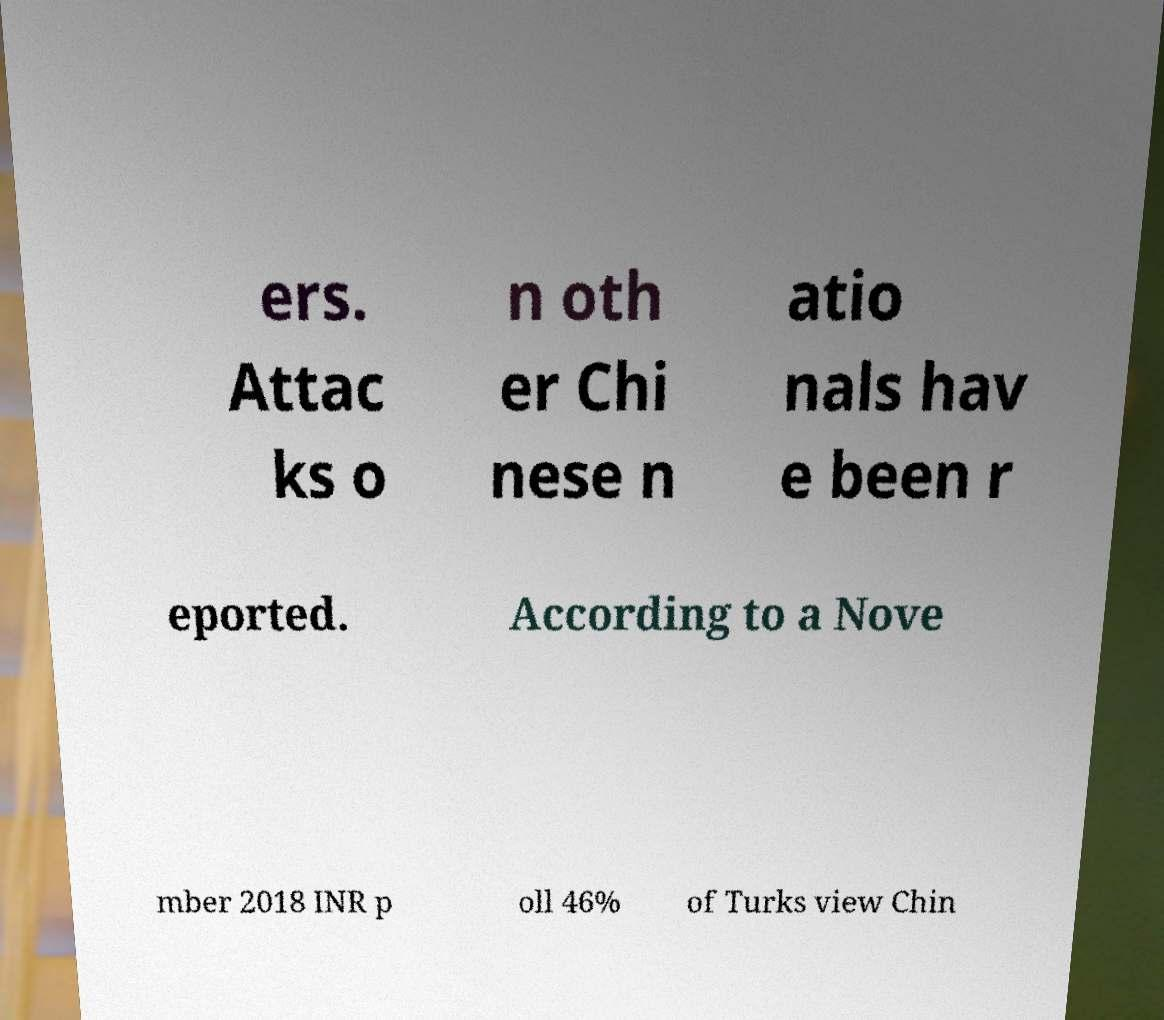I need the written content from this picture converted into text. Can you do that? ers. Attac ks o n oth er Chi nese n atio nals hav e been r eported. According to a Nove mber 2018 INR p oll 46% of Turks view Chin 